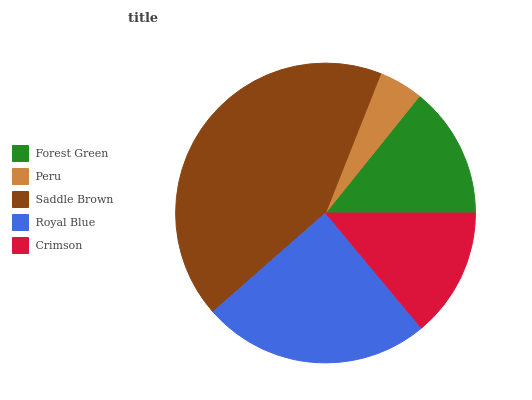Is Peru the minimum?
Answer yes or no. Yes. Is Saddle Brown the maximum?
Answer yes or no. Yes. Is Saddle Brown the minimum?
Answer yes or no. No. Is Peru the maximum?
Answer yes or no. No. Is Saddle Brown greater than Peru?
Answer yes or no. Yes. Is Peru less than Saddle Brown?
Answer yes or no. Yes. Is Peru greater than Saddle Brown?
Answer yes or no. No. Is Saddle Brown less than Peru?
Answer yes or no. No. Is Forest Green the high median?
Answer yes or no. Yes. Is Forest Green the low median?
Answer yes or no. Yes. Is Crimson the high median?
Answer yes or no. No. Is Royal Blue the low median?
Answer yes or no. No. 